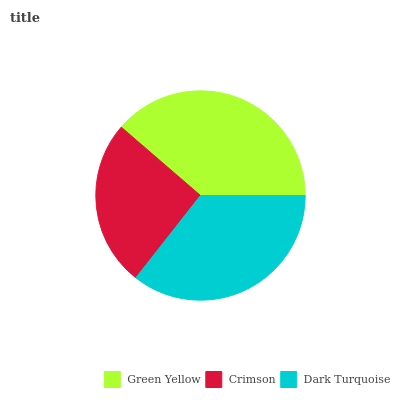Is Crimson the minimum?
Answer yes or no. Yes. Is Green Yellow the maximum?
Answer yes or no. Yes. Is Dark Turquoise the minimum?
Answer yes or no. No. Is Dark Turquoise the maximum?
Answer yes or no. No. Is Dark Turquoise greater than Crimson?
Answer yes or no. Yes. Is Crimson less than Dark Turquoise?
Answer yes or no. Yes. Is Crimson greater than Dark Turquoise?
Answer yes or no. No. Is Dark Turquoise less than Crimson?
Answer yes or no. No. Is Dark Turquoise the high median?
Answer yes or no. Yes. Is Dark Turquoise the low median?
Answer yes or no. Yes. Is Green Yellow the high median?
Answer yes or no. No. Is Green Yellow the low median?
Answer yes or no. No. 